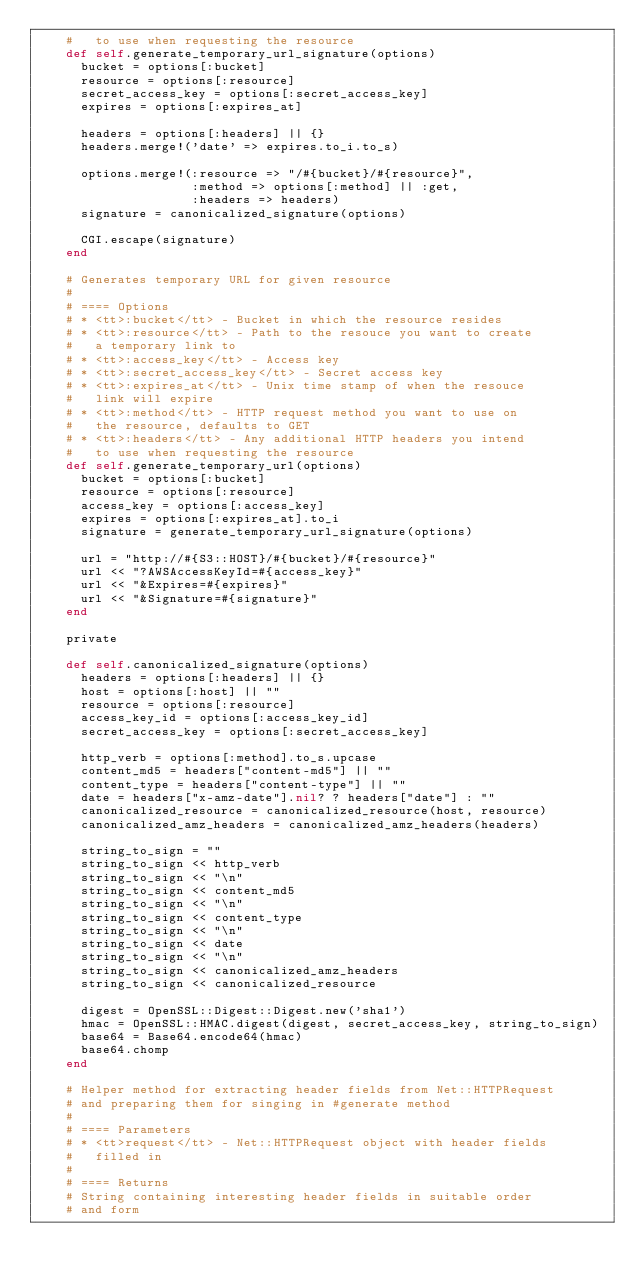Convert code to text. <code><loc_0><loc_0><loc_500><loc_500><_Ruby_>    #   to use when requesting the resource
    def self.generate_temporary_url_signature(options)
      bucket = options[:bucket]
      resource = options[:resource]
      secret_access_key = options[:secret_access_key]
      expires = options[:expires_at]

      headers = options[:headers] || {}
      headers.merge!('date' => expires.to_i.to_s)

      options.merge!(:resource => "/#{bucket}/#{resource}",
                     :method => options[:method] || :get,
                     :headers => headers)
      signature = canonicalized_signature(options)

      CGI.escape(signature)
    end

    # Generates temporary URL for given resource
    #
    # ==== Options
    # * <tt>:bucket</tt> - Bucket in which the resource resides
    # * <tt>:resource</tt> - Path to the resouce you want to create
    #   a temporary link to
    # * <tt>:access_key</tt> - Access key
    # * <tt>:secret_access_key</tt> - Secret access key
    # * <tt>:expires_at</tt> - Unix time stamp of when the resouce
    #   link will expire
    # * <tt>:method</tt> - HTTP request method you want to use on
    #   the resource, defaults to GET
    # * <tt>:headers</tt> - Any additional HTTP headers you intend
    #   to use when requesting the resource
    def self.generate_temporary_url(options)
      bucket = options[:bucket]
      resource = options[:resource]
      access_key = options[:access_key]
      expires = options[:expires_at].to_i
      signature = generate_temporary_url_signature(options)

      url = "http://#{S3::HOST}/#{bucket}/#{resource}"
      url << "?AWSAccessKeyId=#{access_key}"
      url << "&Expires=#{expires}"
      url << "&Signature=#{signature}"
    end

    private

    def self.canonicalized_signature(options)
      headers = options[:headers] || {}
      host = options[:host] || ""
      resource = options[:resource]
      access_key_id = options[:access_key_id]
      secret_access_key = options[:secret_access_key]

      http_verb = options[:method].to_s.upcase
      content_md5 = headers["content-md5"] || ""
      content_type = headers["content-type"] || ""
      date = headers["x-amz-date"].nil? ? headers["date"] : ""
      canonicalized_resource = canonicalized_resource(host, resource)
      canonicalized_amz_headers = canonicalized_amz_headers(headers)

      string_to_sign = ""
      string_to_sign << http_verb
      string_to_sign << "\n"
      string_to_sign << content_md5
      string_to_sign << "\n"
      string_to_sign << content_type
      string_to_sign << "\n"
      string_to_sign << date
      string_to_sign << "\n"
      string_to_sign << canonicalized_amz_headers
      string_to_sign << canonicalized_resource

      digest = OpenSSL::Digest::Digest.new('sha1')
      hmac = OpenSSL::HMAC.digest(digest, secret_access_key, string_to_sign)
      base64 = Base64.encode64(hmac)
      base64.chomp
    end

    # Helper method for extracting header fields from Net::HTTPRequest
    # and preparing them for singing in #generate method
    #
    # ==== Parameters
    # * <tt>request</tt> - Net::HTTPRequest object with header fields
    #   filled in
    #
    # ==== Returns
    # String containing interesting header fields in suitable order
    # and form</code> 